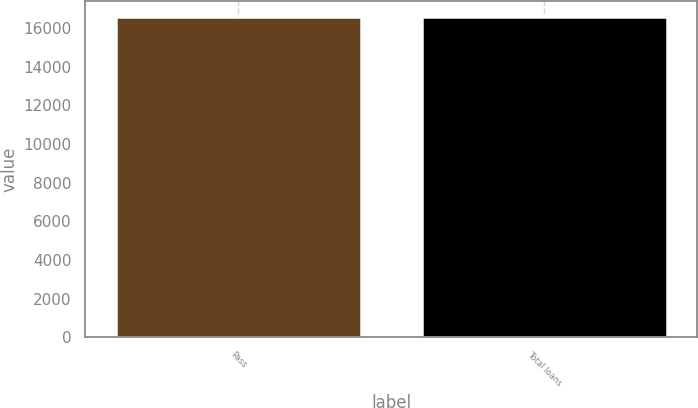Convert chart. <chart><loc_0><loc_0><loc_500><loc_500><bar_chart><fcel>Pass<fcel>Total loans<nl><fcel>16576<fcel>16576.1<nl></chart> 